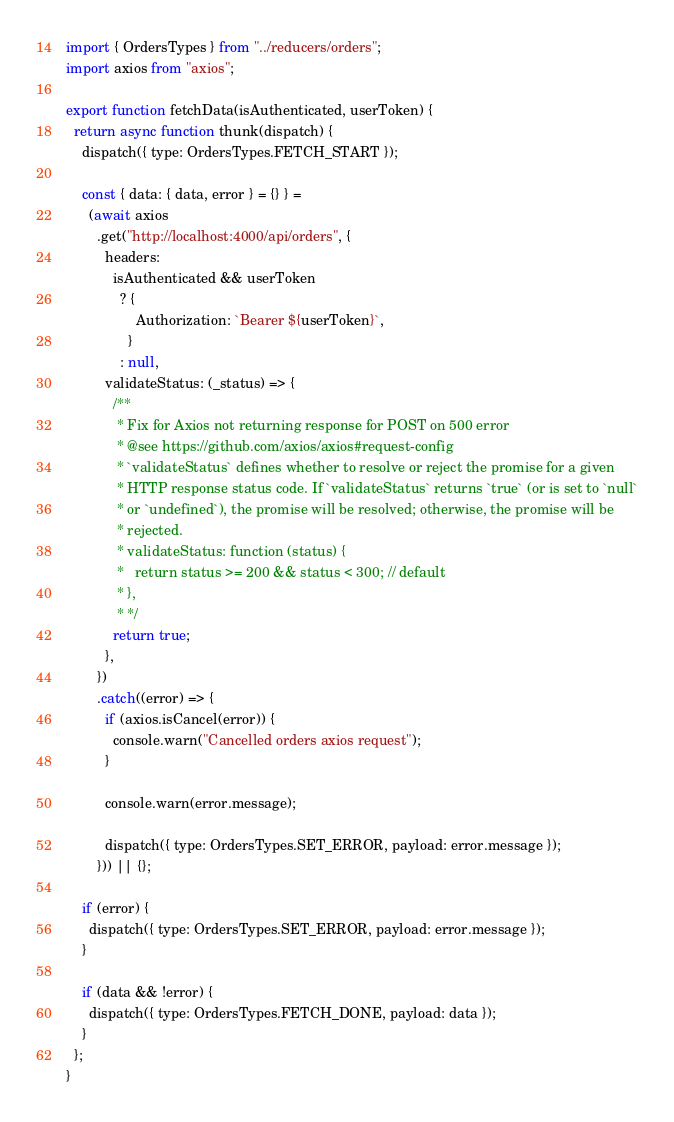Convert code to text. <code><loc_0><loc_0><loc_500><loc_500><_JavaScript_>import { OrdersTypes } from "../reducers/orders";
import axios from "axios";

export function fetchData(isAuthenticated, userToken) {
  return async function thunk(dispatch) {
    dispatch({ type: OrdersTypes.FETCH_START });

    const { data: { data, error } = {} } =
      (await axios
        .get("http://localhost:4000/api/orders", {
          headers:
            isAuthenticated && userToken
              ? {
                  Authorization: `Bearer ${userToken}`,
                }
              : null,
          validateStatus: (_status) => {
            /**
             * Fix for Axios not returning response for POST on 500 error
             * @see https://github.com/axios/axios#request-config
             * `validateStatus` defines whether to resolve or reject the promise for a given
             * HTTP response status code. If `validateStatus` returns `true` (or is set to `null`
             * or `undefined`), the promise will be resolved; otherwise, the promise will be
             * rejected.
             * validateStatus: function (status) {
             *   return status >= 200 && status < 300; // default
             * },
             * */
            return true;
          },
        })
        .catch((error) => {
          if (axios.isCancel(error)) {
            console.warn("Cancelled orders axios request");
          }

          console.warn(error.message);

          dispatch({ type: OrdersTypes.SET_ERROR, payload: error.message });
        })) || {};

    if (error) {
      dispatch({ type: OrdersTypes.SET_ERROR, payload: error.message });
    }

    if (data && !error) {
      dispatch({ type: OrdersTypes.FETCH_DONE, payload: data });
    }
  };
}
</code> 